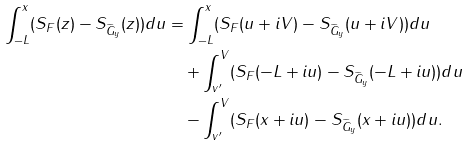Convert formula to latex. <formula><loc_0><loc_0><loc_500><loc_500>\int _ { - L } ^ { x } ( S _ { F } ( z ) - S _ { \widetilde { G } _ { y } } ( z ) ) d u & = \int _ { - L } ^ { x } ( S _ { F } ( u + i V ) - S _ { \widetilde { G } _ { y } } ( u + i V ) ) d u \\ & \quad + \int _ { v ^ { \prime } } ^ { V } ( S _ { F } ( - L + i u ) - S _ { \widetilde { G } _ { y } } ( - L + i u ) ) d u \\ & \quad - \int _ { v ^ { \prime } } ^ { V } ( S _ { F } ( x + i u ) - S _ { \widetilde { G } _ { y } } ( x + i u ) ) d u .</formula> 